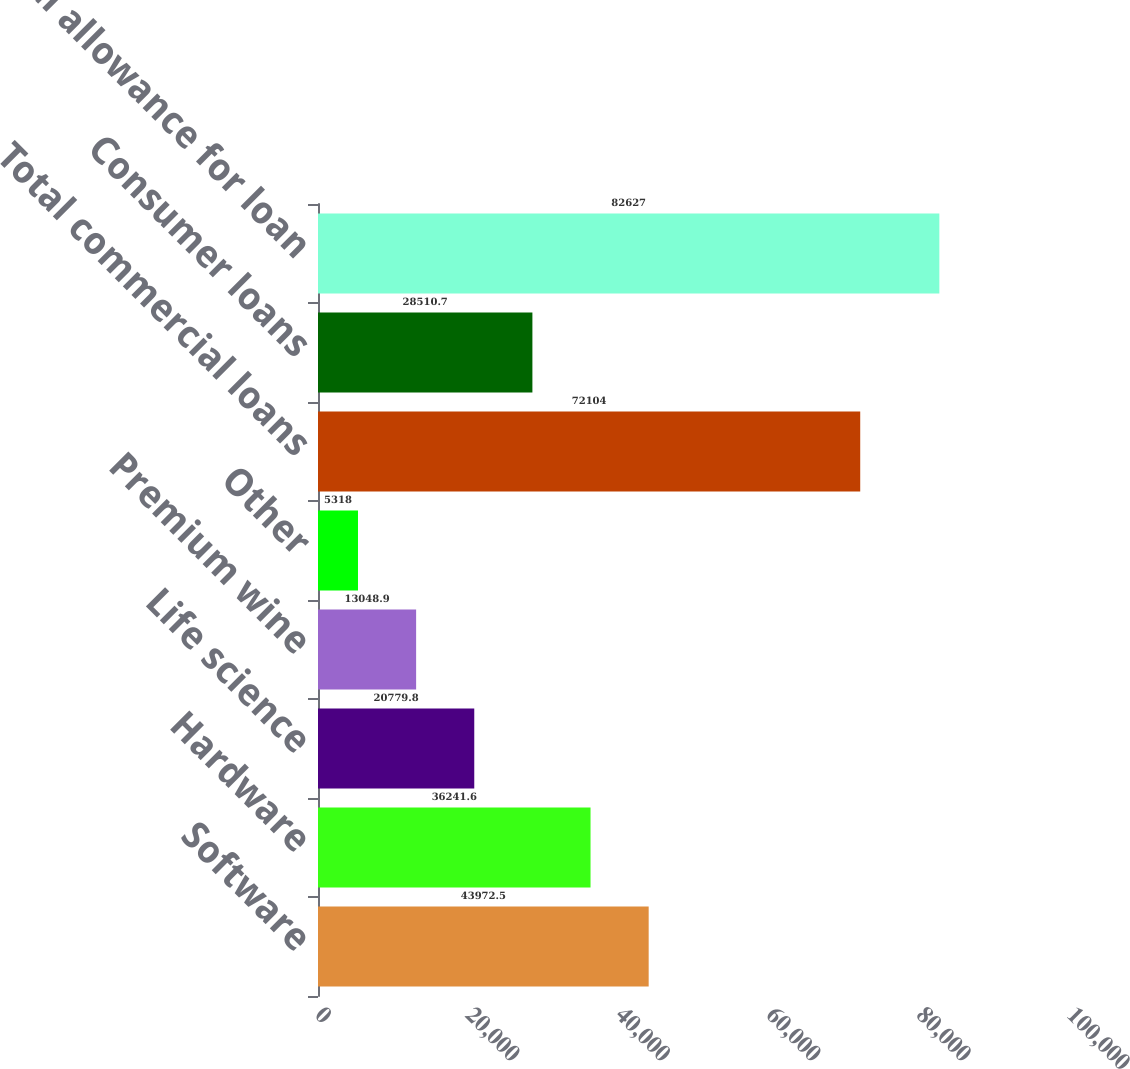<chart> <loc_0><loc_0><loc_500><loc_500><bar_chart><fcel>Software<fcel>Hardware<fcel>Life science<fcel>Premium wine<fcel>Other<fcel>Total commercial loans<fcel>Consumer loans<fcel>Total allowance for loan<nl><fcel>43972.5<fcel>36241.6<fcel>20779.8<fcel>13048.9<fcel>5318<fcel>72104<fcel>28510.7<fcel>82627<nl></chart> 